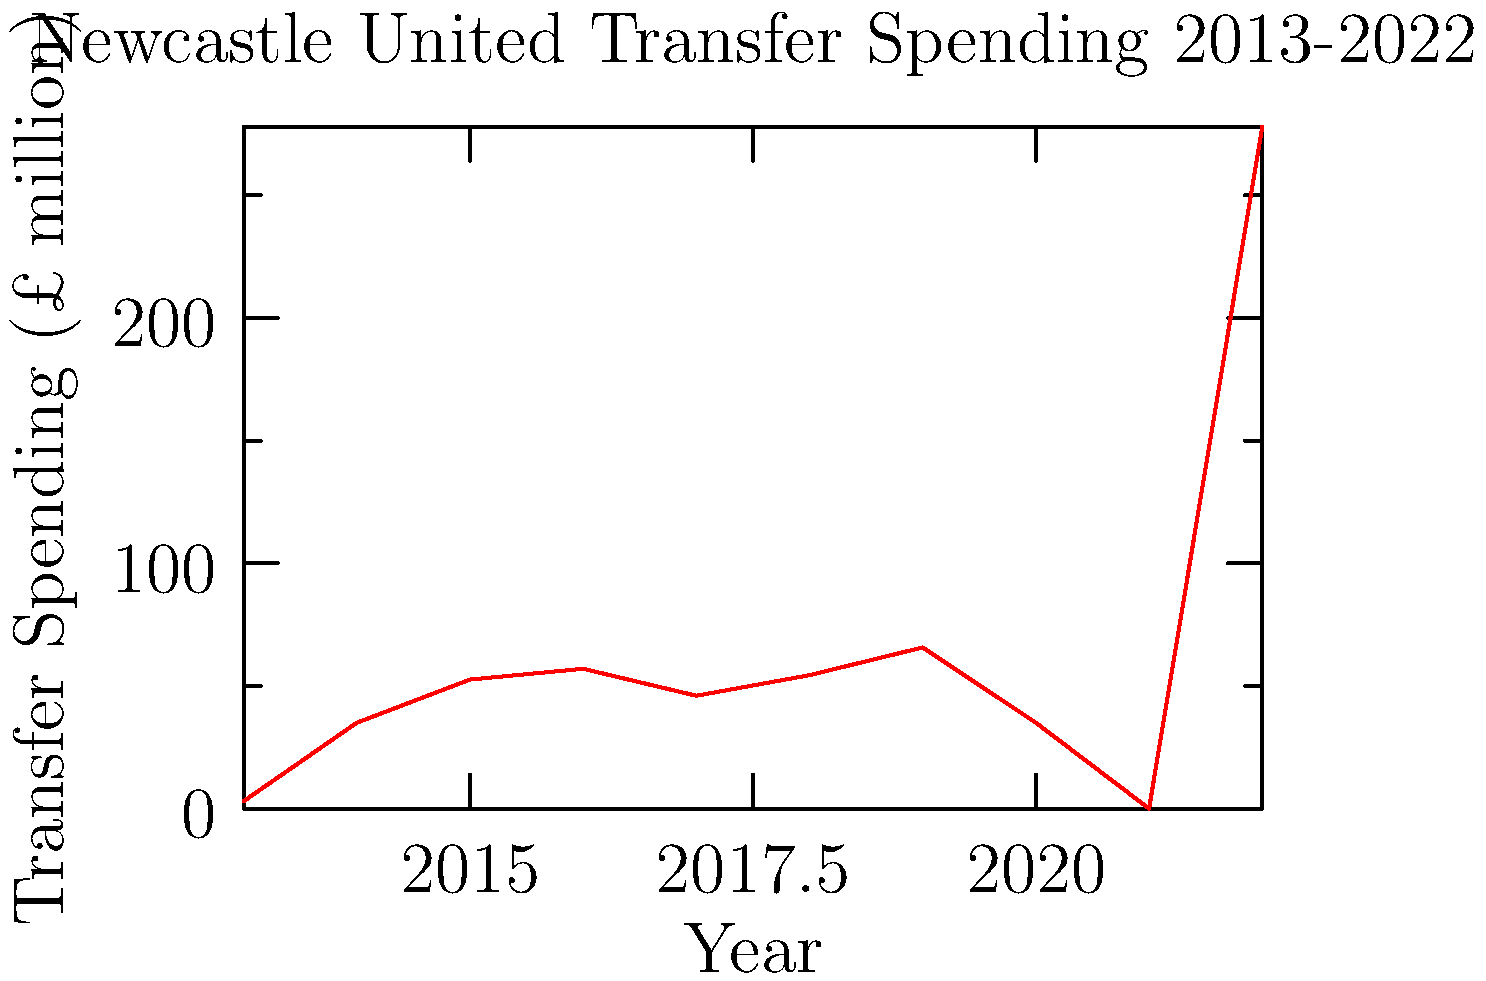Based on the line graph depicting Newcastle United's transfer spending from 2013 to 2022, which year saw the most significant increase in transfer expenditure compared to the previous year? To determine the year with the most significant increase in transfer spending compared to the previous year, we need to:

1. Calculate the year-on-year change in spending for each consecutive pair of years.
2. Identify the largest positive change.

Year-on-year changes:
2013 to 2014: £35m - £3m = £32m increase
2014 to 2015: £52.6m - £35m = £17.6m increase
2015 to 2016: £57m - £52.6m = £4.4m increase
2016 to 2017: £46m - £57m = £11m decrease
2017 to 2018: £54.4m - £46m = £8.4m increase
2018 to 2019: £65.7m - £54.4m = £11.3m increase
2019 to 2020: £35m - £65.7m = £30.7m decrease
2020 to 2021: £0m - £35m = £35m decrease
2021 to 2022: £278m - £0m = £278m increase

The largest increase is £278m, occurring from 2021 to 2022.
Answer: 2022 